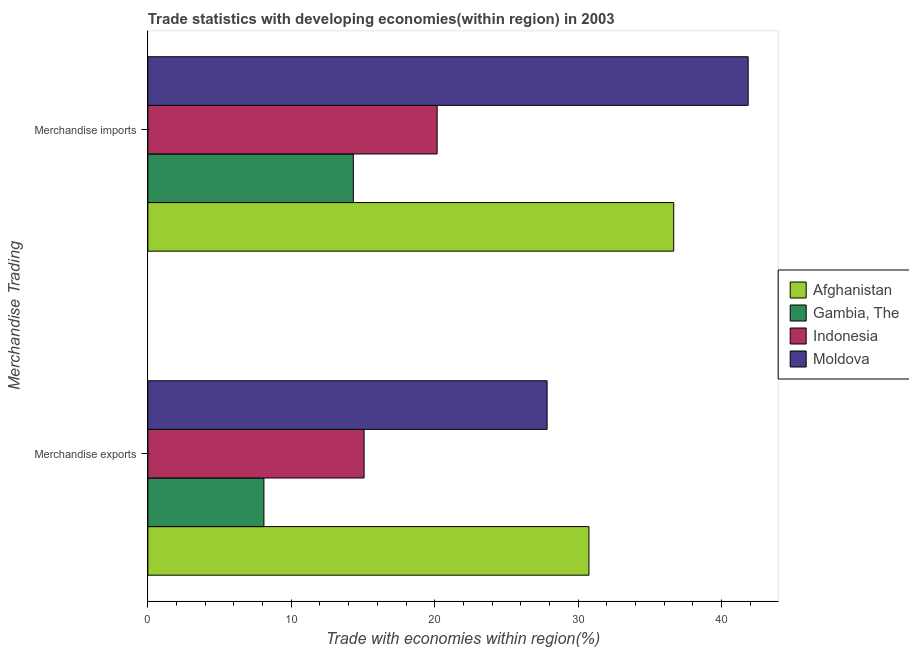How many different coloured bars are there?
Provide a short and direct response. 4. How many bars are there on the 2nd tick from the bottom?
Your answer should be compact. 4. What is the merchandise exports in Afghanistan?
Ensure brevity in your answer.  30.76. Across all countries, what is the maximum merchandise exports?
Offer a terse response. 30.76. Across all countries, what is the minimum merchandise exports?
Provide a short and direct response. 8.09. In which country was the merchandise imports maximum?
Keep it short and to the point. Moldova. In which country was the merchandise exports minimum?
Keep it short and to the point. Gambia, The. What is the total merchandise exports in the graph?
Provide a succinct answer. 81.77. What is the difference between the merchandise exports in Indonesia and that in Moldova?
Provide a short and direct response. -12.76. What is the difference between the merchandise imports in Moldova and the merchandise exports in Afghanistan?
Provide a short and direct response. 11.1. What is the average merchandise exports per country?
Your answer should be very brief. 20.44. What is the difference between the merchandise imports and merchandise exports in Indonesia?
Give a very brief answer. 5.09. What is the ratio of the merchandise imports in Afghanistan to that in Gambia, The?
Your answer should be compact. 2.56. In how many countries, is the merchandise exports greater than the average merchandise exports taken over all countries?
Your answer should be very brief. 2. What does the 1st bar from the bottom in Merchandise imports represents?
Offer a terse response. Afghanistan. How many bars are there?
Keep it short and to the point. 8. How many countries are there in the graph?
Give a very brief answer. 4. What is the difference between two consecutive major ticks on the X-axis?
Ensure brevity in your answer.  10. Does the graph contain grids?
Provide a succinct answer. No. Where does the legend appear in the graph?
Offer a very short reply. Center right. How are the legend labels stacked?
Provide a succinct answer. Vertical. What is the title of the graph?
Make the answer very short. Trade statistics with developing economies(within region) in 2003. Does "Sri Lanka" appear as one of the legend labels in the graph?
Your answer should be compact. No. What is the label or title of the X-axis?
Offer a terse response. Trade with economies within region(%). What is the label or title of the Y-axis?
Provide a short and direct response. Merchandise Trading. What is the Trade with economies within region(%) of Afghanistan in Merchandise exports?
Ensure brevity in your answer.  30.76. What is the Trade with economies within region(%) in Gambia, The in Merchandise exports?
Your response must be concise. 8.09. What is the Trade with economies within region(%) of Indonesia in Merchandise exports?
Make the answer very short. 15.08. What is the Trade with economies within region(%) in Moldova in Merchandise exports?
Provide a succinct answer. 27.84. What is the Trade with economies within region(%) of Afghanistan in Merchandise imports?
Your answer should be compact. 36.67. What is the Trade with economies within region(%) of Gambia, The in Merchandise imports?
Your response must be concise. 14.33. What is the Trade with economies within region(%) in Indonesia in Merchandise imports?
Provide a short and direct response. 20.17. What is the Trade with economies within region(%) of Moldova in Merchandise imports?
Give a very brief answer. 41.86. Across all Merchandise Trading, what is the maximum Trade with economies within region(%) of Afghanistan?
Keep it short and to the point. 36.67. Across all Merchandise Trading, what is the maximum Trade with economies within region(%) of Gambia, The?
Offer a very short reply. 14.33. Across all Merchandise Trading, what is the maximum Trade with economies within region(%) in Indonesia?
Keep it short and to the point. 20.17. Across all Merchandise Trading, what is the maximum Trade with economies within region(%) of Moldova?
Your answer should be very brief. 41.86. Across all Merchandise Trading, what is the minimum Trade with economies within region(%) of Afghanistan?
Make the answer very short. 30.76. Across all Merchandise Trading, what is the minimum Trade with economies within region(%) of Gambia, The?
Provide a succinct answer. 8.09. Across all Merchandise Trading, what is the minimum Trade with economies within region(%) of Indonesia?
Keep it short and to the point. 15.08. Across all Merchandise Trading, what is the minimum Trade with economies within region(%) in Moldova?
Provide a succinct answer. 27.84. What is the total Trade with economies within region(%) of Afghanistan in the graph?
Ensure brevity in your answer.  67.42. What is the total Trade with economies within region(%) of Gambia, The in the graph?
Ensure brevity in your answer.  22.42. What is the total Trade with economies within region(%) of Indonesia in the graph?
Your answer should be compact. 35.25. What is the total Trade with economies within region(%) of Moldova in the graph?
Your response must be concise. 69.7. What is the difference between the Trade with economies within region(%) of Afghanistan in Merchandise exports and that in Merchandise imports?
Make the answer very short. -5.91. What is the difference between the Trade with economies within region(%) of Gambia, The in Merchandise exports and that in Merchandise imports?
Offer a very short reply. -6.23. What is the difference between the Trade with economies within region(%) in Indonesia in Merchandise exports and that in Merchandise imports?
Give a very brief answer. -5.09. What is the difference between the Trade with economies within region(%) of Moldova in Merchandise exports and that in Merchandise imports?
Ensure brevity in your answer.  -14.02. What is the difference between the Trade with economies within region(%) in Afghanistan in Merchandise exports and the Trade with economies within region(%) in Gambia, The in Merchandise imports?
Ensure brevity in your answer.  16.43. What is the difference between the Trade with economies within region(%) in Afghanistan in Merchandise exports and the Trade with economies within region(%) in Indonesia in Merchandise imports?
Give a very brief answer. 10.59. What is the difference between the Trade with economies within region(%) of Afghanistan in Merchandise exports and the Trade with economies within region(%) of Moldova in Merchandise imports?
Keep it short and to the point. -11.1. What is the difference between the Trade with economies within region(%) of Gambia, The in Merchandise exports and the Trade with economies within region(%) of Indonesia in Merchandise imports?
Provide a succinct answer. -12.08. What is the difference between the Trade with economies within region(%) in Gambia, The in Merchandise exports and the Trade with economies within region(%) in Moldova in Merchandise imports?
Give a very brief answer. -33.77. What is the difference between the Trade with economies within region(%) of Indonesia in Merchandise exports and the Trade with economies within region(%) of Moldova in Merchandise imports?
Provide a succinct answer. -26.78. What is the average Trade with economies within region(%) in Afghanistan per Merchandise Trading?
Your answer should be compact. 33.71. What is the average Trade with economies within region(%) of Gambia, The per Merchandise Trading?
Offer a terse response. 11.21. What is the average Trade with economies within region(%) in Indonesia per Merchandise Trading?
Offer a very short reply. 17.62. What is the average Trade with economies within region(%) in Moldova per Merchandise Trading?
Give a very brief answer. 34.85. What is the difference between the Trade with economies within region(%) in Afghanistan and Trade with economies within region(%) in Gambia, The in Merchandise exports?
Provide a succinct answer. 22.66. What is the difference between the Trade with economies within region(%) of Afghanistan and Trade with economies within region(%) of Indonesia in Merchandise exports?
Offer a terse response. 15.68. What is the difference between the Trade with economies within region(%) of Afghanistan and Trade with economies within region(%) of Moldova in Merchandise exports?
Make the answer very short. 2.92. What is the difference between the Trade with economies within region(%) of Gambia, The and Trade with economies within region(%) of Indonesia in Merchandise exports?
Your response must be concise. -6.98. What is the difference between the Trade with economies within region(%) of Gambia, The and Trade with economies within region(%) of Moldova in Merchandise exports?
Your answer should be compact. -19.75. What is the difference between the Trade with economies within region(%) of Indonesia and Trade with economies within region(%) of Moldova in Merchandise exports?
Give a very brief answer. -12.76. What is the difference between the Trade with economies within region(%) of Afghanistan and Trade with economies within region(%) of Gambia, The in Merchandise imports?
Offer a terse response. 22.34. What is the difference between the Trade with economies within region(%) in Afghanistan and Trade with economies within region(%) in Indonesia in Merchandise imports?
Your response must be concise. 16.5. What is the difference between the Trade with economies within region(%) in Afghanistan and Trade with economies within region(%) in Moldova in Merchandise imports?
Ensure brevity in your answer.  -5.19. What is the difference between the Trade with economies within region(%) in Gambia, The and Trade with economies within region(%) in Indonesia in Merchandise imports?
Give a very brief answer. -5.84. What is the difference between the Trade with economies within region(%) in Gambia, The and Trade with economies within region(%) in Moldova in Merchandise imports?
Ensure brevity in your answer.  -27.53. What is the difference between the Trade with economies within region(%) of Indonesia and Trade with economies within region(%) of Moldova in Merchandise imports?
Give a very brief answer. -21.69. What is the ratio of the Trade with economies within region(%) of Afghanistan in Merchandise exports to that in Merchandise imports?
Give a very brief answer. 0.84. What is the ratio of the Trade with economies within region(%) in Gambia, The in Merchandise exports to that in Merchandise imports?
Make the answer very short. 0.56. What is the ratio of the Trade with economies within region(%) of Indonesia in Merchandise exports to that in Merchandise imports?
Your answer should be very brief. 0.75. What is the ratio of the Trade with economies within region(%) of Moldova in Merchandise exports to that in Merchandise imports?
Your response must be concise. 0.67. What is the difference between the highest and the second highest Trade with economies within region(%) of Afghanistan?
Your answer should be compact. 5.91. What is the difference between the highest and the second highest Trade with economies within region(%) in Gambia, The?
Offer a terse response. 6.23. What is the difference between the highest and the second highest Trade with economies within region(%) of Indonesia?
Provide a short and direct response. 5.09. What is the difference between the highest and the second highest Trade with economies within region(%) of Moldova?
Keep it short and to the point. 14.02. What is the difference between the highest and the lowest Trade with economies within region(%) in Afghanistan?
Ensure brevity in your answer.  5.91. What is the difference between the highest and the lowest Trade with economies within region(%) of Gambia, The?
Give a very brief answer. 6.23. What is the difference between the highest and the lowest Trade with economies within region(%) in Indonesia?
Your answer should be compact. 5.09. What is the difference between the highest and the lowest Trade with economies within region(%) of Moldova?
Your response must be concise. 14.02. 